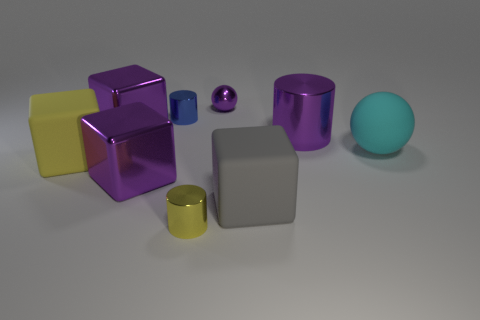How does the lighting in this scene affect the appearance of the objects? The lighting in the scene has a diffused quality, softening shadows and reducing harsh contrasts on the objects' surfaces. Reflective materials, like the metallic cylinders, capture and reflect the light, accentuating their glossy texture. For the rubber and plastic materials, the soft light maintains their matte appearance and reveals subtle details like edges and curves. Overall, the lighting enhances the objects' three-dimensionality and gives depth to their colors. 